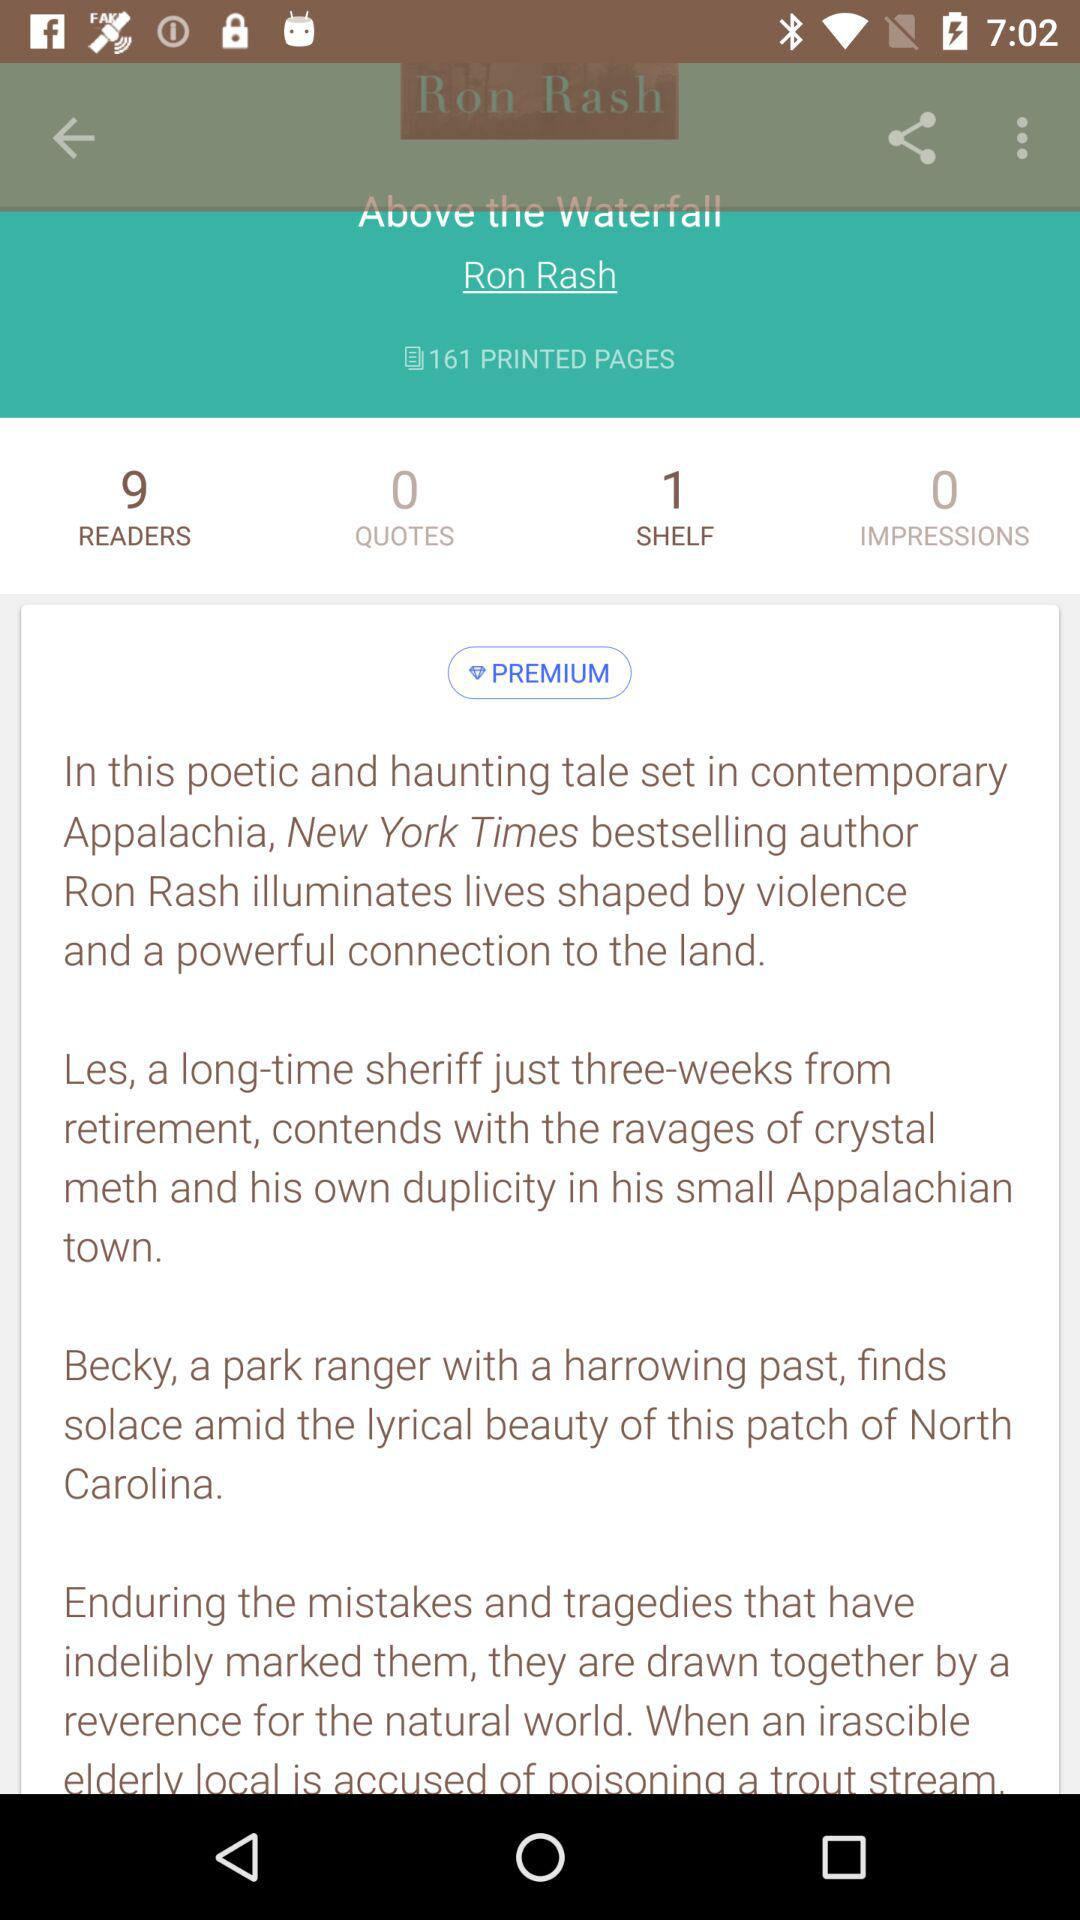How many printed pages are there? There are 161 printed pages. 